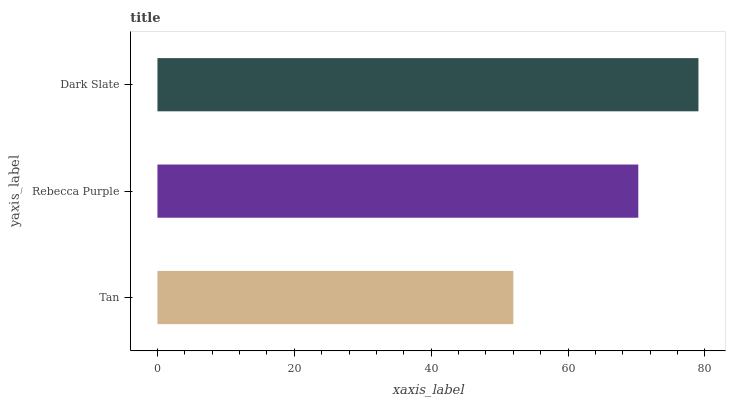Is Tan the minimum?
Answer yes or no. Yes. Is Dark Slate the maximum?
Answer yes or no. Yes. Is Rebecca Purple the minimum?
Answer yes or no. No. Is Rebecca Purple the maximum?
Answer yes or no. No. Is Rebecca Purple greater than Tan?
Answer yes or no. Yes. Is Tan less than Rebecca Purple?
Answer yes or no. Yes. Is Tan greater than Rebecca Purple?
Answer yes or no. No. Is Rebecca Purple less than Tan?
Answer yes or no. No. Is Rebecca Purple the high median?
Answer yes or no. Yes. Is Rebecca Purple the low median?
Answer yes or no. Yes. Is Dark Slate the high median?
Answer yes or no. No. Is Dark Slate the low median?
Answer yes or no. No. 